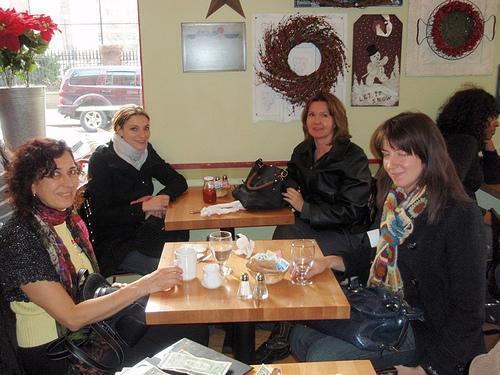How many women are wearing scarves?
Give a very brief answer. 3. How many people are at each table?
Give a very brief answer. 2. How many people are in the picture?
Give a very brief answer. 5. How many handbags can you see?
Give a very brief answer. 3. How many dining tables are visible?
Give a very brief answer. 2. How many giraffes are there?
Give a very brief answer. 0. 